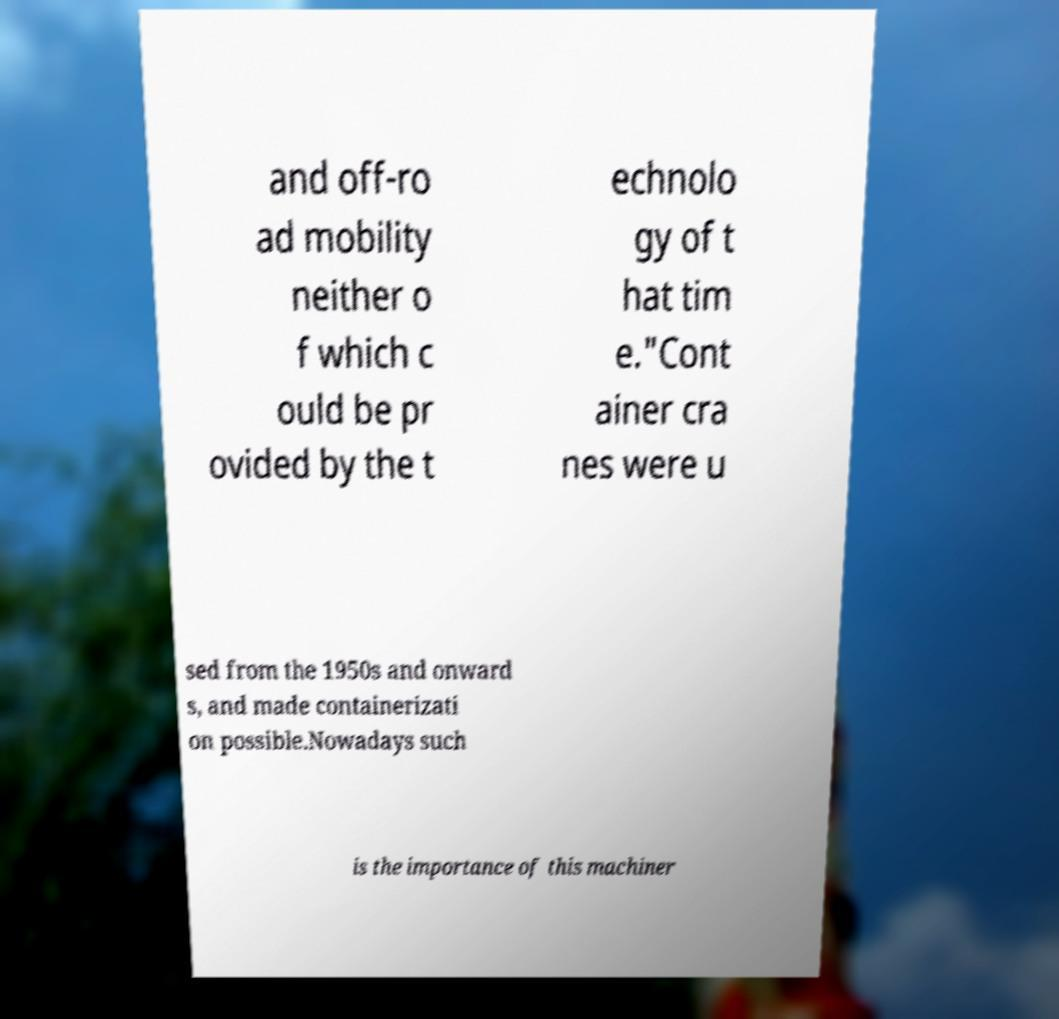Could you extract and type out the text from this image? and off-ro ad mobility neither o f which c ould be pr ovided by the t echnolo gy of t hat tim e."Cont ainer cra nes were u sed from the 1950s and onward s, and made containerizati on possible.Nowadays such is the importance of this machiner 